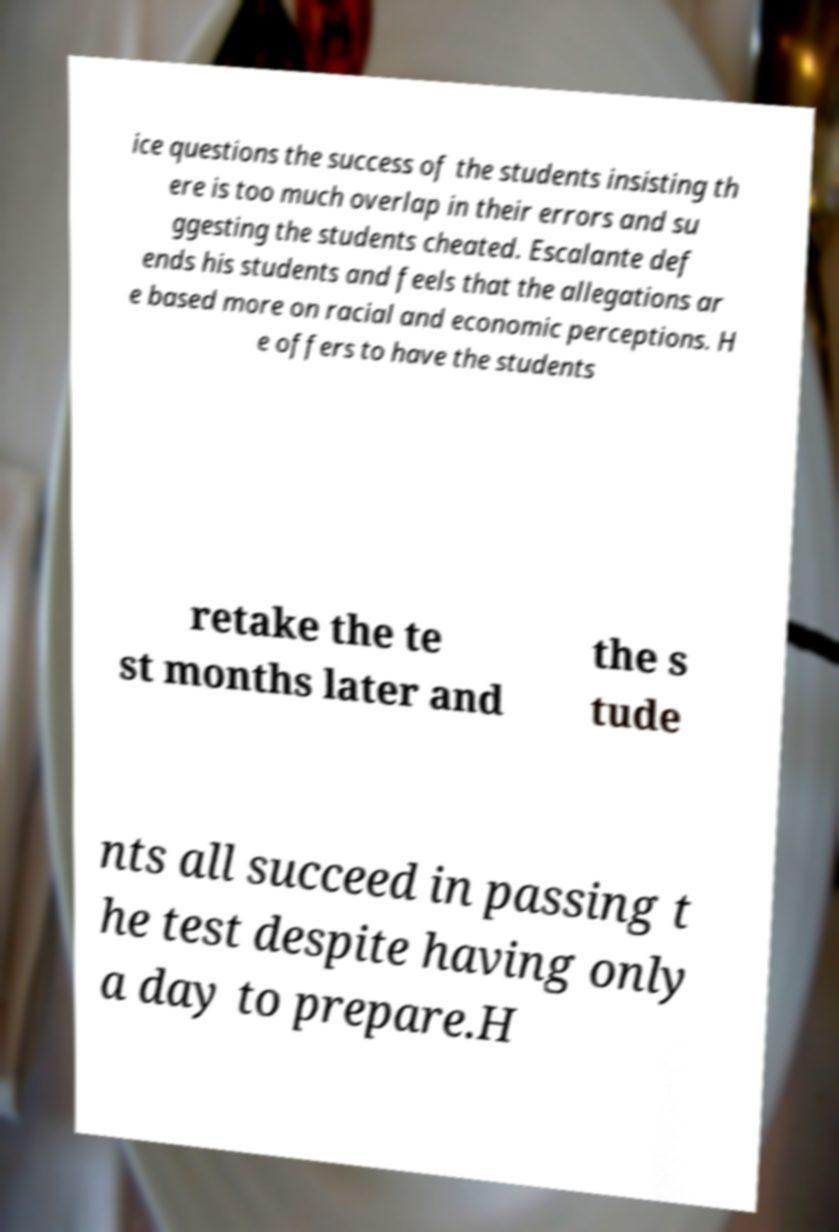What messages or text are displayed in this image? I need them in a readable, typed format. ice questions the success of the students insisting th ere is too much overlap in their errors and su ggesting the students cheated. Escalante def ends his students and feels that the allegations ar e based more on racial and economic perceptions. H e offers to have the students retake the te st months later and the s tude nts all succeed in passing t he test despite having only a day to prepare.H 